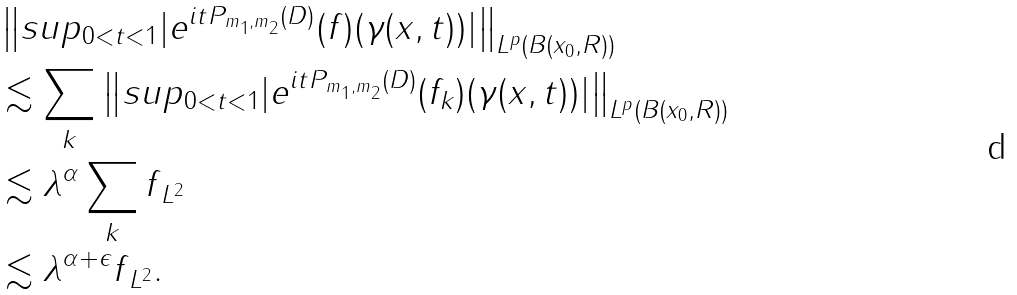Convert formula to latex. <formula><loc_0><loc_0><loc_500><loc_500>& \left \| s u p _ { 0 < t < 1 } | e ^ { i t P _ { m _ { 1 } , m _ { 2 } } ( D ) } ( f ) ( \gamma ( x , t ) ) | \right \| _ { L ^ { p } ( B ( x _ { 0 } , R ) ) } \\ & \lesssim \sum _ { k } \left \| s u p _ { 0 < t < 1 } | e ^ { i t P _ { m _ { 1 } , m _ { 2 } } ( D ) } ( f _ { k } ) ( \gamma ( x , t ) ) | \right \| _ { L ^ { p } ( B ( x _ { 0 } , R ) ) } \\ & \lesssim \lambda ^ { \alpha } \sum _ { k } \| f \| _ { L ^ { 2 } } \\ & \lesssim \lambda ^ { \alpha + \epsilon } \| f \| _ { L ^ { 2 } } .</formula> 